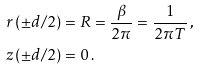Convert formula to latex. <formula><loc_0><loc_0><loc_500><loc_500>r \left ( \pm d / 2 \right ) & = R = \frac { \beta } { 2 \pi } = \frac { 1 } { 2 \pi T } \, , \\ z \left ( \pm d / 2 \right ) & = 0 \, .</formula> 